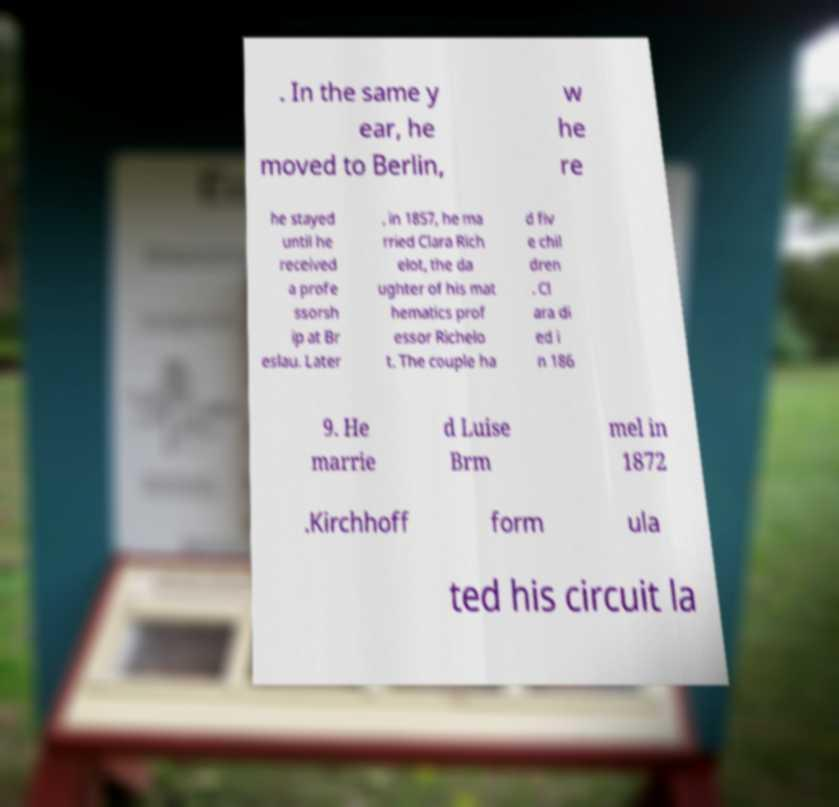What messages or text are displayed in this image? I need them in a readable, typed format. . In the same y ear, he moved to Berlin, w he re he stayed until he received a profe ssorsh ip at Br eslau. Later , in 1857, he ma rried Clara Rich elot, the da ughter of his mat hematics prof essor Richelo t. The couple ha d fiv e chil dren . Cl ara di ed i n 186 9. He marrie d Luise Brm mel in 1872 .Kirchhoff form ula ted his circuit la 